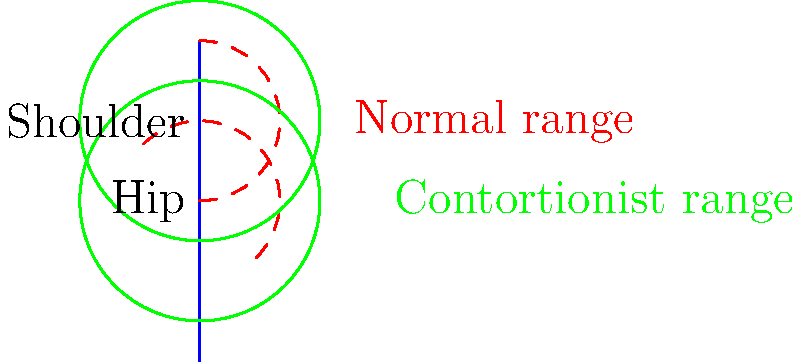In your latest magical thriller, you're describing a contortionist escaping from a locked chest. Based on the flexibility range diagram, what biomechanical advantage do contortionists have over average individuals, and how might this affect their ability to escape confined spaces? To answer this question, let's analyze the diagram step-by-step:

1. Normal flexibility range (red dashed lines):
   - Shoulder: approximately $180^\circ$ ($-90^\circ$ to $90^\circ$)
   - Hip: approximately $180^\circ$ ($-45^\circ$ to $135^\circ$)

2. Contortionist flexibility range (green solid lines):
   - Shoulder: $360^\circ$ ($-180^\circ$ to $180^\circ$)
   - Hip: $360^\circ$ ($-135^\circ$ to $225^\circ$)

3. Biomechanical advantages of contortionists:
   a) Greater range of motion: Contortionists can move their joints through a much wider arc than average individuals.
   b) Increased flexibility: Their muscles, tendons, and ligaments are more elastic, allowing for extreme positions.
   c) Enhanced joint mobility: Contortionists often have hypermobile joints, which can dislocate and relocate safely.

4. Impact on escaping confined spaces:
   a) Ability to compress body: The increased range of motion allows contortionists to fold their bodies into smaller shapes.
   b) Unusual positions: They can twist and bend into positions that would be impossible for most people, potentially finding gaps or weak points in the confinement.
   c) Leverage: The extreme flexibility gives them more options for applying force from unconventional angles.

5. In the context of escaping a locked chest:
   a) A contortionist could potentially bend their body to reach locks or hinges that would be inaccessible to others.
   b) They might be able to position themselves to apply maximum force to weak points in the chest's structure.
   c) The ability to compress their body could allow them to fit through smaller openings or create space to maneuver within the chest.
Answer: Contortionists have a significantly larger range of motion (up to $360^\circ$ at major joints vs. $180^\circ$ for average individuals), allowing them to compress their bodies, assume unusual positions, and apply leverage from unconventional angles when escaping confined spaces. 